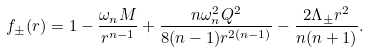<formula> <loc_0><loc_0><loc_500><loc_500>f _ { \pm } ( r ) = 1 - \frac { \omega _ { n } M } { r ^ { n - 1 } } + \frac { n \omega _ { n } ^ { 2 } Q ^ { 2 } } { 8 ( n - 1 ) r ^ { 2 ( n - 1 ) } } - \frac { 2 \Lambda _ { \pm } r ^ { 2 } } { n ( n + 1 ) } .</formula> 